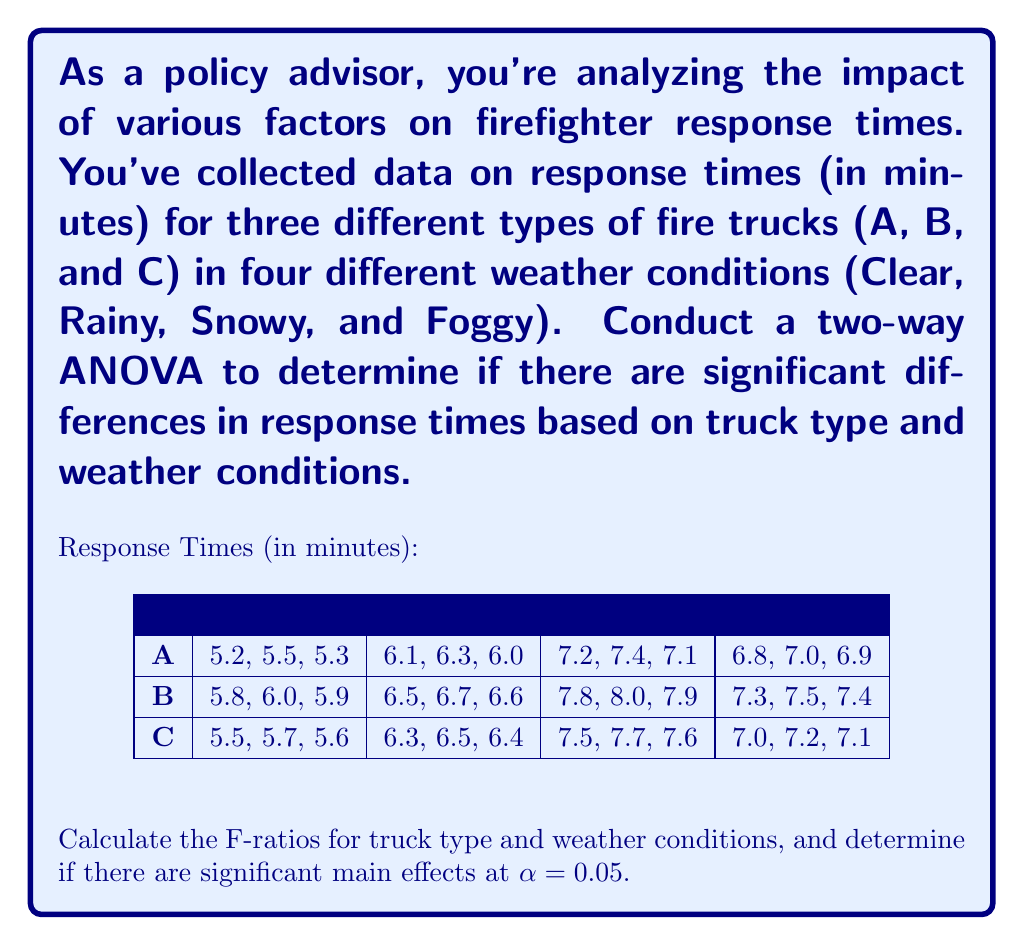Provide a solution to this math problem. To conduct a two-way ANOVA, we need to follow these steps:

1. Calculate the sum of squares for truck type (SS_A), weather conditions (SS_B), interaction (SS_AB), within groups (SS_W), and total (SS_T).

2. Calculate the degrees of freedom for each source of variation.

3. Calculate the mean squares by dividing sum of squares by degrees of freedom.

4. Calculate the F-ratios by dividing mean squares by MS_W.

5. Compare the F-ratios to the critical F-values at α = 0.05.

Step 1: Calculate sums of squares

First, we need to calculate the grand mean and total sum of squares:

Grand Mean = $\frac{\text{Sum of all observations}}{\text{Total number of observations}} = 6.675$

SS_T = $\sum (x_i - \bar{x})^2 = 36.495$

For SS_A (truck type):
SS_A = $n_j \sum_j (\bar{x_j} - \bar{x})^2 = 2.34$

For SS_B (weather conditions):
SS_B = $n_i \sum_i (\bar{x_i} - \bar{x})^2 = 32.085$

For SS_AB (interaction):
SS_AB = $\sum_{ij} n_{ij} (\bar{x_{ij}} - \bar{x_i} - \bar{x_j} + \bar{x})^2 = 0.03$

SS_W = SS_T - SS_A - SS_B - SS_AB = 2.04

Step 2: Calculate degrees of freedom

df_A = 2 (3 truck types - 1)
df_B = 3 (4 weather conditions - 1)
df_AB = 6 (df_A * df_B)
df_W = 24 (36 total observations - 12 groups)
df_T = 35 (36 total observations - 1)

Step 3: Calculate mean squares

MS_A = SS_A / df_A = 1.17
MS_B = SS_B / df_B = 10.695
MS_AB = SS_AB / df_AB = 0.005
MS_W = SS_W / df_W = 0.085

Step 4: Calculate F-ratios

F_A = MS_A / MS_W = 13.765
F_B = MS_B / MS_W = 125.824

Step 5: Compare to critical F-values

Critical F-value for truck type (α = 0.05, df1 = 2, df2 = 24): 3.40
Critical F-value for weather conditions (α = 0.05, df1 = 3, df2 = 24): 3.01

Both F_A and F_B are greater than their respective critical F-values, indicating significant main effects for both truck type and weather conditions.
Answer: F_A = 13.765, F_B = 125.824; both truck type and weather conditions have significant main effects (p < 0.05). 